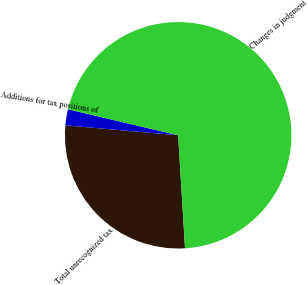<chart> <loc_0><loc_0><loc_500><loc_500><pie_chart><fcel>Total unrecognized tax<fcel>Additions for tax positions of<fcel>Changes in judgment<nl><fcel>27.37%<fcel>2.29%<fcel>70.34%<nl></chart> 